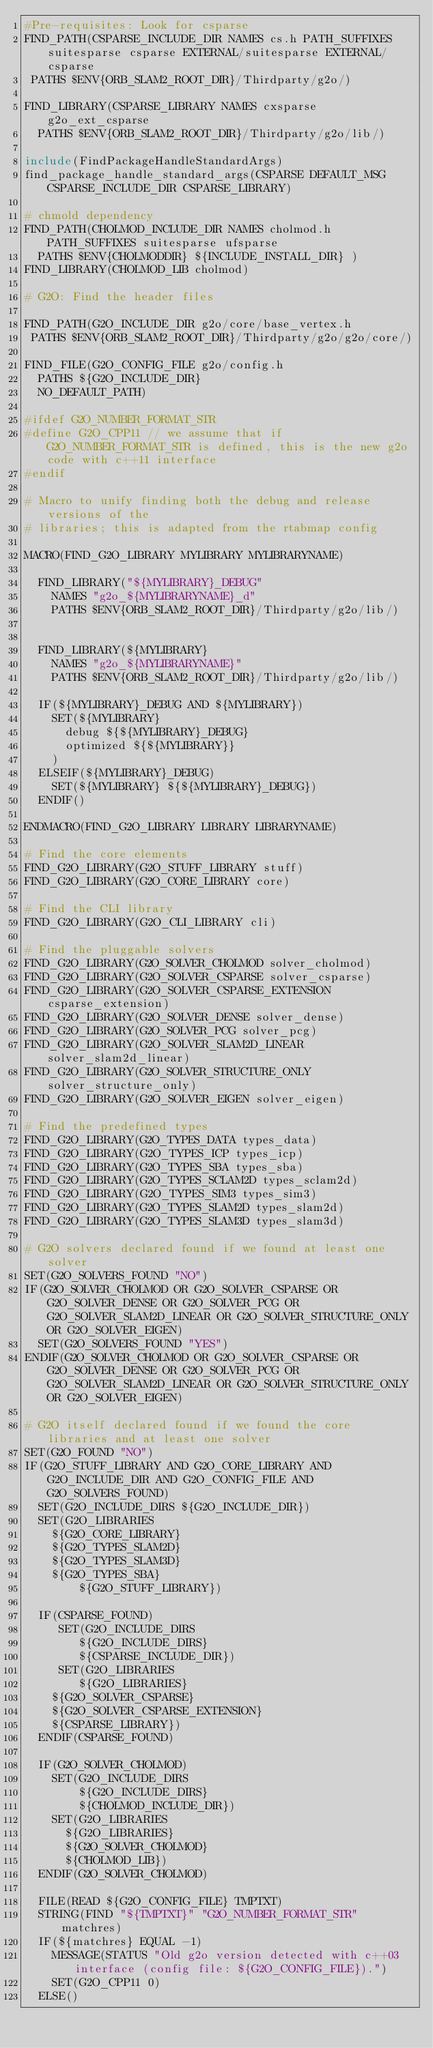<code> <loc_0><loc_0><loc_500><loc_500><_CMake_>#Pre-requisites: Look for csparse
FIND_PATH(CSPARSE_INCLUDE_DIR NAMES cs.h PATH_SUFFIXES suitesparse csparse EXTERNAL/suitesparse EXTERNAL/csparse
 PATHS $ENV{ORB_SLAM2_ROOT_DIR}/Thirdparty/g2o/)

FIND_LIBRARY(CSPARSE_LIBRARY NAMES cxsparse g2o_ext_csparse 
  PATHS $ENV{ORB_SLAM2_ROOT_DIR}/Thirdparty/g2o/lib/)

include(FindPackageHandleStandardArgs)
find_package_handle_standard_args(CSPARSE DEFAULT_MSG CSPARSE_INCLUDE_DIR CSPARSE_LIBRARY)

# chmold dependency
FIND_PATH(CHOLMOD_INCLUDE_DIR NAMES cholmod.h PATH_SUFFIXES suitesparse ufsparse
  PATHS $ENV{CHOLMODDIR} ${INCLUDE_INSTALL_DIR} )
FIND_LIBRARY(CHOLMOD_LIB cholmod)

# G2O: Find the header files

FIND_PATH(G2O_INCLUDE_DIR g2o/core/base_vertex.h 
 PATHS $ENV{ORB_SLAM2_ROOT_DIR}/Thirdparty/g2o/g2o/core/)

FIND_FILE(G2O_CONFIG_FILE g2o/config.h 
  PATHS ${G2O_INCLUDE_DIR}
  NO_DEFAULT_PATH)

#ifdef G2O_NUMBER_FORMAT_STR
#define G2O_CPP11 // we assume that if G2O_NUMBER_FORMAT_STR is defined, this is the new g2o code with c++11 interface
#endif

# Macro to unify finding both the debug and release versions of the
# libraries; this is adapted from the rtabmap config

MACRO(FIND_G2O_LIBRARY MYLIBRARY MYLIBRARYNAME)

  FIND_LIBRARY("${MYLIBRARY}_DEBUG"
    NAMES "g2o_${MYLIBRARYNAME}_d"
	PATHS $ENV{ORB_SLAM2_ROOT_DIR}/Thirdparty/g2o/lib/)

  
  FIND_LIBRARY(${MYLIBRARY}
    NAMES "g2o_${MYLIBRARYNAME}"
	PATHS $ENV{ORB_SLAM2_ROOT_DIR}/Thirdparty/g2o/lib/)
  
  IF(${MYLIBRARY}_DEBUG AND ${MYLIBRARY})
    SET(${MYLIBRARY}
      debug ${${MYLIBRARY}_DEBUG}
      optimized ${${MYLIBRARY}}
    )
  ELSEIF(${MYLIBRARY}_DEBUG)
    SET(${MYLIBRARY} ${${MYLIBRARY}_DEBUG})
  ENDIF()  
  
ENDMACRO(FIND_G2O_LIBRARY LIBRARY LIBRARYNAME)

# Find the core elements
FIND_G2O_LIBRARY(G2O_STUFF_LIBRARY stuff)
FIND_G2O_LIBRARY(G2O_CORE_LIBRARY core)

# Find the CLI library
FIND_G2O_LIBRARY(G2O_CLI_LIBRARY cli)

# Find the pluggable solvers
FIND_G2O_LIBRARY(G2O_SOLVER_CHOLMOD solver_cholmod)
FIND_G2O_LIBRARY(G2O_SOLVER_CSPARSE solver_csparse)
FIND_G2O_LIBRARY(G2O_SOLVER_CSPARSE_EXTENSION csparse_extension)
FIND_G2O_LIBRARY(G2O_SOLVER_DENSE solver_dense)
FIND_G2O_LIBRARY(G2O_SOLVER_PCG solver_pcg)
FIND_G2O_LIBRARY(G2O_SOLVER_SLAM2D_LINEAR solver_slam2d_linear)
FIND_G2O_LIBRARY(G2O_SOLVER_STRUCTURE_ONLY solver_structure_only)
FIND_G2O_LIBRARY(G2O_SOLVER_EIGEN solver_eigen)

# Find the predefined types
FIND_G2O_LIBRARY(G2O_TYPES_DATA types_data)
FIND_G2O_LIBRARY(G2O_TYPES_ICP types_icp)
FIND_G2O_LIBRARY(G2O_TYPES_SBA types_sba)
FIND_G2O_LIBRARY(G2O_TYPES_SCLAM2D types_sclam2d)
FIND_G2O_LIBRARY(G2O_TYPES_SIM3 types_sim3)
FIND_G2O_LIBRARY(G2O_TYPES_SLAM2D types_slam2d)
FIND_G2O_LIBRARY(G2O_TYPES_SLAM3D types_slam3d)

# G2O solvers declared found if we found at least one solver
SET(G2O_SOLVERS_FOUND "NO")
IF(G2O_SOLVER_CHOLMOD OR G2O_SOLVER_CSPARSE OR G2O_SOLVER_DENSE OR G2O_SOLVER_PCG OR G2O_SOLVER_SLAM2D_LINEAR OR G2O_SOLVER_STRUCTURE_ONLY OR G2O_SOLVER_EIGEN)
  SET(G2O_SOLVERS_FOUND "YES")
ENDIF(G2O_SOLVER_CHOLMOD OR G2O_SOLVER_CSPARSE OR G2O_SOLVER_DENSE OR G2O_SOLVER_PCG OR G2O_SOLVER_SLAM2D_LINEAR OR G2O_SOLVER_STRUCTURE_ONLY OR G2O_SOLVER_EIGEN)

# G2O itself declared found if we found the core libraries and at least one solver
SET(G2O_FOUND "NO")
IF(G2O_STUFF_LIBRARY AND G2O_CORE_LIBRARY AND G2O_INCLUDE_DIR AND G2O_CONFIG_FILE AND G2O_SOLVERS_FOUND)
  SET(G2O_INCLUDE_DIRS ${G2O_INCLUDE_DIR})
  SET(G2O_LIBRARIES 
	${G2O_CORE_LIBRARY}
	${G2O_TYPES_SLAM2D} 
	${G2O_TYPES_SLAM3D}
	${G2O_TYPES_SBA}
        ${G2O_STUFF_LIBRARY})
  
  IF(CSPARSE_FOUND)
     SET(G2O_INCLUDE_DIRS 
        ${G2O_INCLUDE_DIRS} 
        ${CSPARSE_INCLUDE_DIR})
     SET(G2O_LIBRARIES
        ${G2O_LIBRARIES} 
	${G2O_SOLVER_CSPARSE} 
	${G2O_SOLVER_CSPARSE_EXTENSION}
	${CSPARSE_LIBRARY})
  ENDIF(CSPARSE_FOUND)

  IF(G2O_SOLVER_CHOLMOD)
    SET(G2O_INCLUDE_DIRS 
        ${G2O_INCLUDE_DIRS} 
        ${CHOLMOD_INCLUDE_DIR})
    SET(G2O_LIBRARIES 
	  ${G2O_LIBRARIES}
	  ${G2O_SOLVER_CHOLMOD}
	  ${CHOLMOD_LIB})
  ENDIF(G2O_SOLVER_CHOLMOD)

  FILE(READ ${G2O_CONFIG_FILE} TMPTXT)
  STRING(FIND "${TMPTXT}" "G2O_NUMBER_FORMAT_STR" matchres)
  IF(${matchres} EQUAL -1)
    MESSAGE(STATUS "Old g2o version detected with c++03 interface (config file: ${G2O_CONFIG_FILE}).")
    SET(G2O_CPP11 0)
  ELSE()</code> 